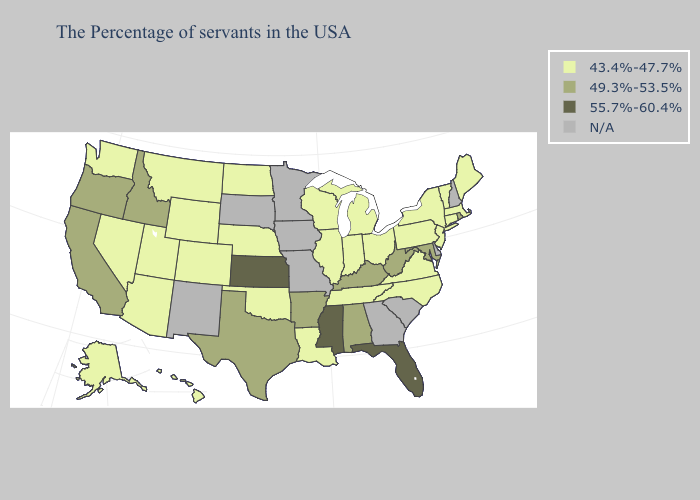What is the lowest value in states that border South Carolina?
Keep it brief. 43.4%-47.7%. Name the states that have a value in the range N/A?
Write a very short answer. New Hampshire, Delaware, South Carolina, Georgia, Missouri, Minnesota, Iowa, South Dakota, New Mexico. What is the lowest value in states that border Arizona?
Concise answer only. 43.4%-47.7%. What is the value of Utah?
Short answer required. 43.4%-47.7%. What is the highest value in states that border Delaware?
Keep it brief. 49.3%-53.5%. What is the lowest value in the USA?
Short answer required. 43.4%-47.7%. Among the states that border California , which have the highest value?
Concise answer only. Oregon. Does the map have missing data?
Concise answer only. Yes. What is the highest value in the USA?
Short answer required. 55.7%-60.4%. What is the value of Hawaii?
Quick response, please. 43.4%-47.7%. Among the states that border Iowa , which have the lowest value?
Be succinct. Wisconsin, Illinois, Nebraska. What is the lowest value in the USA?
Give a very brief answer. 43.4%-47.7%. Name the states that have a value in the range 55.7%-60.4%?
Answer briefly. Florida, Mississippi, Kansas. 